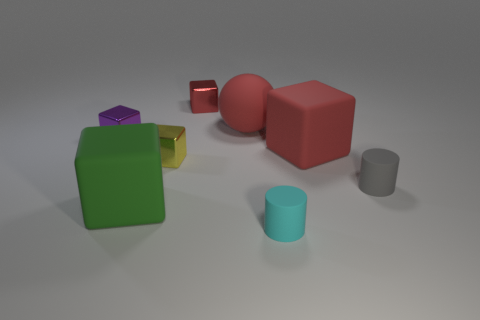Subtract all matte cubes. How many cubes are left? 3 Subtract all green cylinders. How many red cubes are left? 2 Add 1 small green metallic balls. How many objects exist? 9 Subtract all purple blocks. How many blocks are left? 4 Subtract 2 blocks. How many blocks are left? 3 Subtract all balls. How many objects are left? 7 Subtract all blue cubes. Subtract all brown balls. How many cubes are left? 5 Add 2 red matte spheres. How many red matte spheres exist? 3 Subtract 0 gray blocks. How many objects are left? 8 Subtract all green things. Subtract all small gray cylinders. How many objects are left? 6 